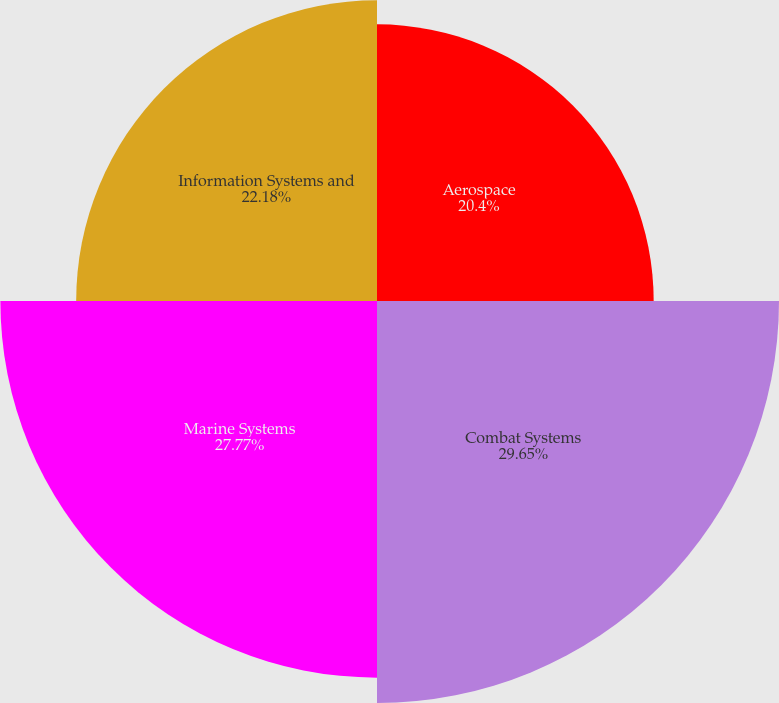<chart> <loc_0><loc_0><loc_500><loc_500><pie_chart><fcel>Aerospace<fcel>Combat Systems<fcel>Marine Systems<fcel>Information Systems and<nl><fcel>20.4%<fcel>29.64%<fcel>27.77%<fcel>22.18%<nl></chart> 